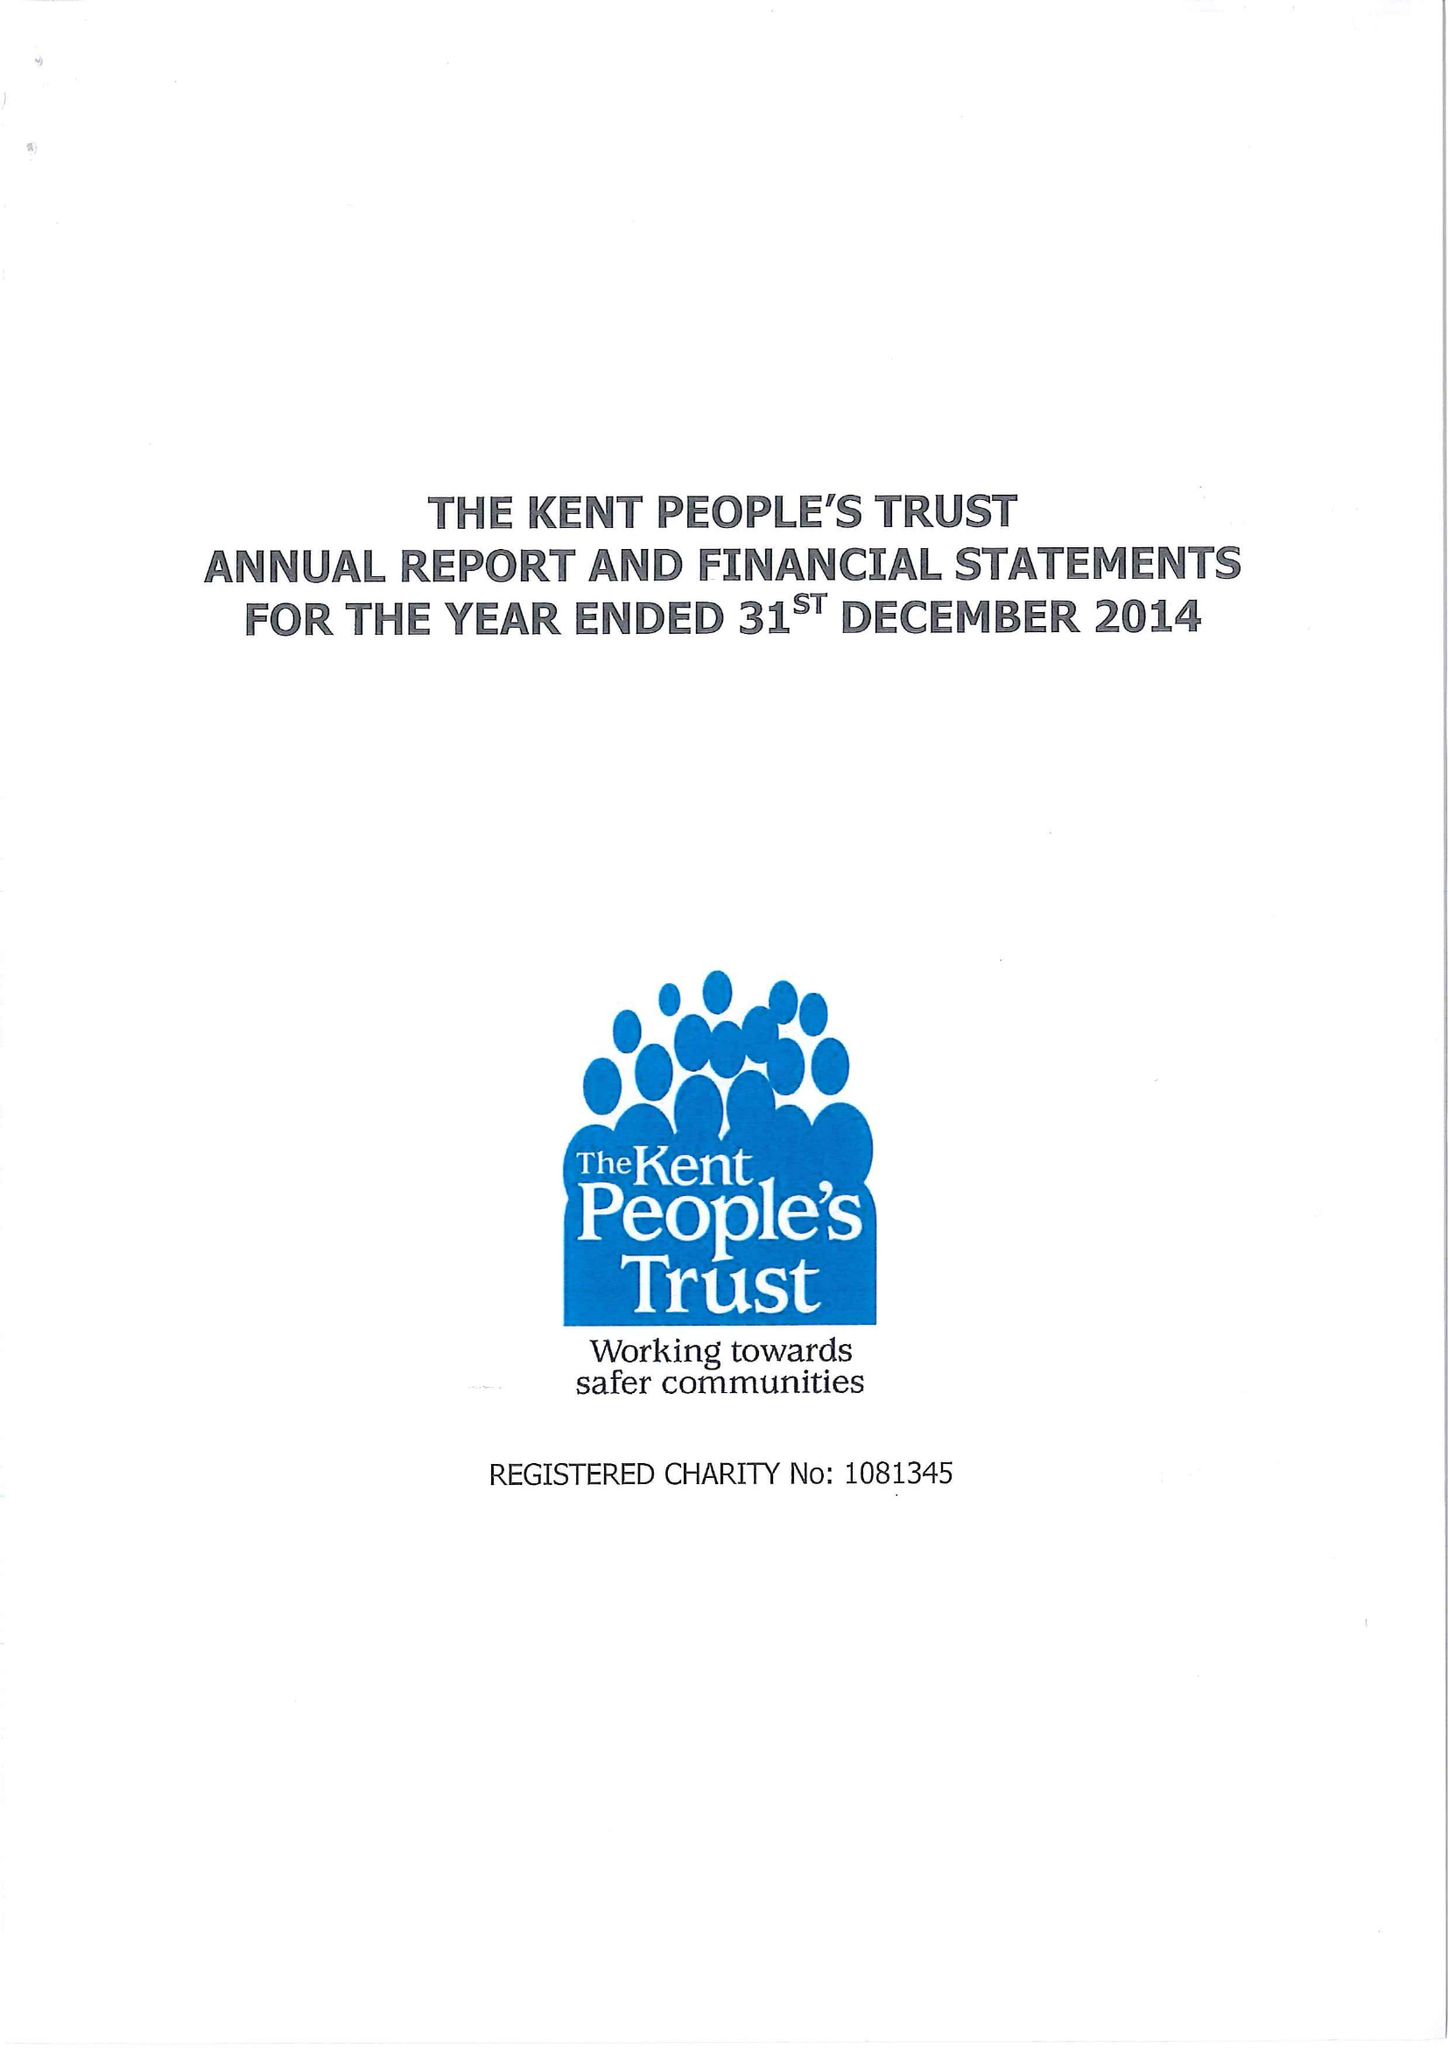What is the value for the address__postcode?
Answer the question using a single word or phrase. ME15 9BZ 